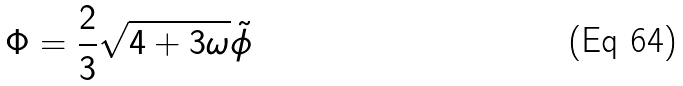Convert formula to latex. <formula><loc_0><loc_0><loc_500><loc_500>\Phi = \frac { 2 } { 3 } \sqrt { 4 + 3 \omega } { \tilde { \phi } }</formula> 